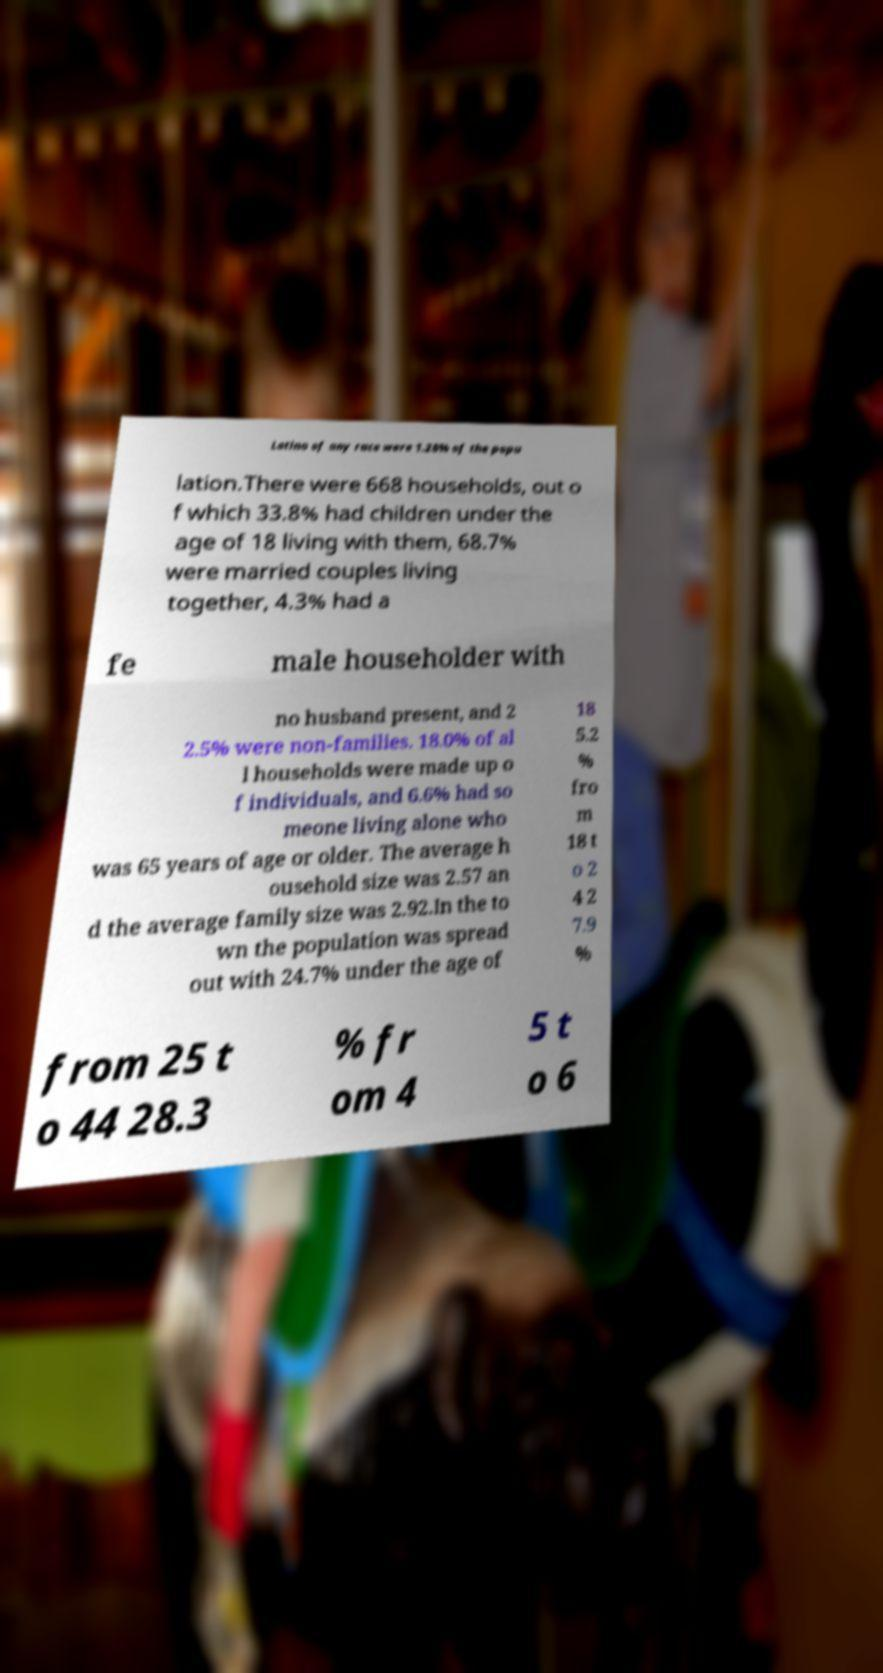For documentation purposes, I need the text within this image transcribed. Could you provide that? Latino of any race were 1.28% of the popu lation.There were 668 households, out o f which 33.8% had children under the age of 18 living with them, 68.7% were married couples living together, 4.3% had a fe male householder with no husband present, and 2 2.5% were non-families. 18.0% of al l households were made up o f individuals, and 6.6% had so meone living alone who was 65 years of age or older. The average h ousehold size was 2.57 an d the average family size was 2.92.In the to wn the population was spread out with 24.7% under the age of 18 5.2 % fro m 18 t o 2 4 2 7.9 % from 25 t o 44 28.3 % fr om 4 5 t o 6 